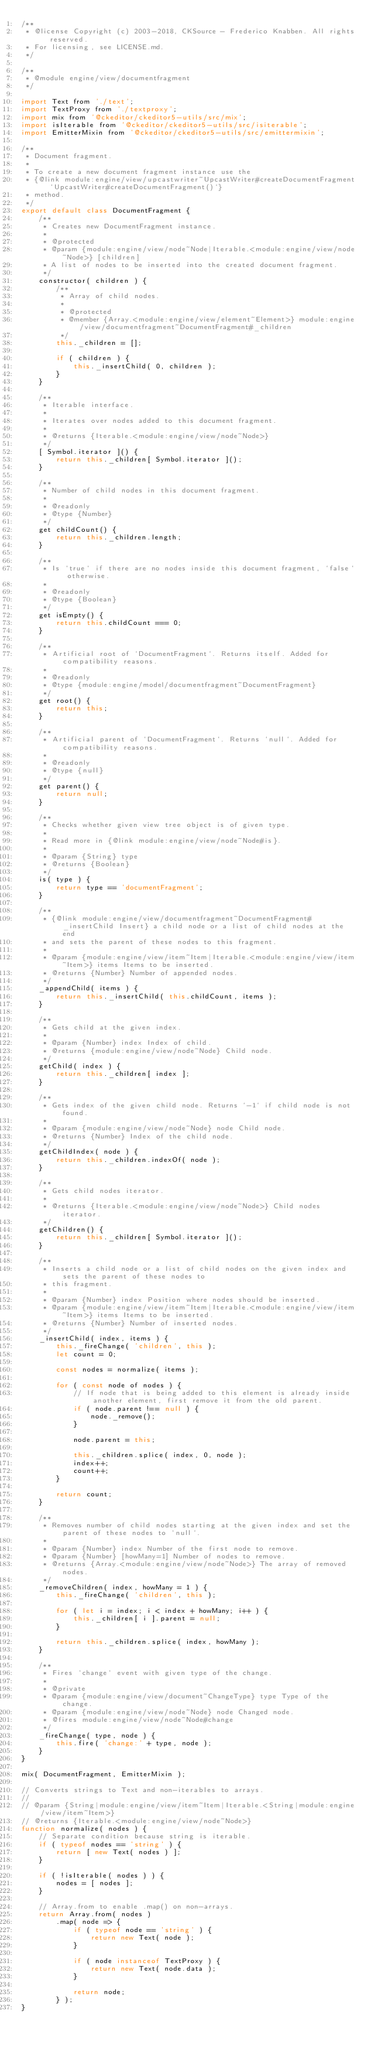<code> <loc_0><loc_0><loc_500><loc_500><_JavaScript_>/**
 * @license Copyright (c) 2003-2018, CKSource - Frederico Knabben. All rights reserved.
 * For licensing, see LICENSE.md.
 */

/**
 * @module engine/view/documentfragment
 */

import Text from './text';
import TextProxy from './textproxy';
import mix from '@ckeditor/ckeditor5-utils/src/mix';
import isIterable from '@ckeditor/ckeditor5-utils/src/isiterable';
import EmitterMixin from '@ckeditor/ckeditor5-utils/src/emittermixin';

/**
 * Document fragment.
 *
 * To create a new document fragment instance use the
 * {@link module:engine/view/upcastwriter~UpcastWriter#createDocumentFragment `UpcastWriter#createDocumentFragment()`}
 * method.
 */
export default class DocumentFragment {
	/**
	 * Creates new DocumentFragment instance.
	 *
	 * @protected
	 * @param {module:engine/view/node~Node|Iterable.<module:engine/view/node~Node>} [children]
	 * A list of nodes to be inserted into the created document fragment.
	 */
	constructor( children ) {
		/**
		 * Array of child nodes.
		 *
		 * @protected
		 * @member {Array.<module:engine/view/element~Element>} module:engine/view/documentfragment~DocumentFragment#_children
		 */
		this._children = [];

		if ( children ) {
			this._insertChild( 0, children );
		}
	}

	/**
	 * Iterable interface.
	 *
	 * Iterates over nodes added to this document fragment.
	 *
	 * @returns {Iterable.<module:engine/view/node~Node>}
	 */
	[ Symbol.iterator ]() {
		return this._children[ Symbol.iterator ]();
	}

	/**
	 * Number of child nodes in this document fragment.
	 *
	 * @readonly
	 * @type {Number}
	 */
	get childCount() {
		return this._children.length;
	}

	/**
	 * Is `true` if there are no nodes inside this document fragment, `false` otherwise.
	 *
	 * @readonly
	 * @type {Boolean}
	 */
	get isEmpty() {
		return this.childCount === 0;
	}

	/**
	 * Artificial root of `DocumentFragment`. Returns itself. Added for compatibility reasons.
	 *
	 * @readonly
	 * @type {module:engine/model/documentfragment~DocumentFragment}
	 */
	get root() {
		return this;
	}

	/**
	 * Artificial parent of `DocumentFragment`. Returns `null`. Added for compatibility reasons.
	 *
	 * @readonly
	 * @type {null}
	 */
	get parent() {
		return null;
	}

	/**
	 * Checks whether given view tree object is of given type.
	 *
	 * Read more in {@link module:engine/view/node~Node#is}.
	 *
	 * @param {String} type
	 * @returns {Boolean}
	 */
	is( type ) {
		return type == 'documentFragment';
	}

	/**
	 * {@link module:engine/view/documentfragment~DocumentFragment#_insertChild Insert} a child node or a list of child nodes at the end
	 * and sets the parent of these nodes to this fragment.
	 *
	 * @param {module:engine/view/item~Item|Iterable.<module:engine/view/item~Item>} items Items to be inserted.
	 * @returns {Number} Number of appended nodes.
	 */
	_appendChild( items ) {
		return this._insertChild( this.childCount, items );
	}

	/**
	 * Gets child at the given index.
	 *
	 * @param {Number} index Index of child.
	 * @returns {module:engine/view/node~Node} Child node.
	 */
	getChild( index ) {
		return this._children[ index ];
	}

	/**
	 * Gets index of the given child node. Returns `-1` if child node is not found.
	 *
	 * @param {module:engine/view/node~Node} node Child node.
	 * @returns {Number} Index of the child node.
	 */
	getChildIndex( node ) {
		return this._children.indexOf( node );
	}

	/**
	 * Gets child nodes iterator.
	 *
	 * @returns {Iterable.<module:engine/view/node~Node>} Child nodes iterator.
	 */
	getChildren() {
		return this._children[ Symbol.iterator ]();
	}

	/**
	 * Inserts a child node or a list of child nodes on the given index and sets the parent of these nodes to
	 * this fragment.
	 *
	 * @param {Number} index Position where nodes should be inserted.
	 * @param {module:engine/view/item~Item|Iterable.<module:engine/view/item~Item>} items Items to be inserted.
	 * @returns {Number} Number of inserted nodes.
	 */
	_insertChild( index, items ) {
		this._fireChange( 'children', this );
		let count = 0;

		const nodes = normalize( items );

		for ( const node of nodes ) {
			// If node that is being added to this element is already inside another element, first remove it from the old parent.
			if ( node.parent !== null ) {
				node._remove();
			}

			node.parent = this;

			this._children.splice( index, 0, node );
			index++;
			count++;
		}

		return count;
	}

	/**
	 * Removes number of child nodes starting at the given index and set the parent of these nodes to `null`.
	 *
	 * @param {Number} index Number of the first node to remove.
	 * @param {Number} [howMany=1] Number of nodes to remove.
	 * @returns {Array.<module:engine/view/node~Node>} The array of removed nodes.
	 */
	_removeChildren( index, howMany = 1 ) {
		this._fireChange( 'children', this );

		for ( let i = index; i < index + howMany; i++ ) {
			this._children[ i ].parent = null;
		}

		return this._children.splice( index, howMany );
	}

	/**
	 * Fires `change` event with given type of the change.
	 *
	 * @private
	 * @param {module:engine/view/document~ChangeType} type Type of the change.
	 * @param {module:engine/view/node~Node} node Changed node.
	 * @fires module:engine/view/node~Node#change
	 */
	_fireChange( type, node ) {
		this.fire( 'change:' + type, node );
	}
}

mix( DocumentFragment, EmitterMixin );

// Converts strings to Text and non-iterables to arrays.
//
// @param {String|module:engine/view/item~Item|Iterable.<String|module:engine/view/item~Item>}
// @returns {Iterable.<module:engine/view/node~Node>}
function normalize( nodes ) {
	// Separate condition because string is iterable.
	if ( typeof nodes == 'string' ) {
		return [ new Text( nodes ) ];
	}

	if ( !isIterable( nodes ) ) {
		nodes = [ nodes ];
	}

	// Array.from to enable .map() on non-arrays.
	return Array.from( nodes )
		.map( node => {
			if ( typeof node == 'string' ) {
				return new Text( node );
			}

			if ( node instanceof TextProxy ) {
				return new Text( node.data );
			}

			return node;
		} );
}
</code> 